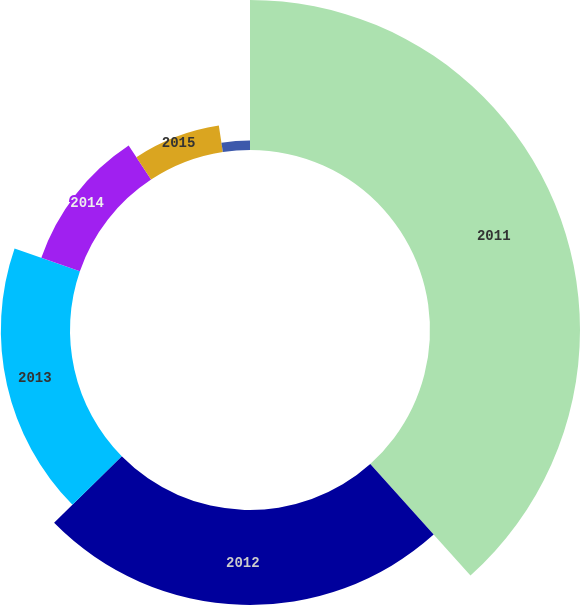<chart> <loc_0><loc_0><loc_500><loc_500><pie_chart><fcel>2011<fcel>2012<fcel>2013<fcel>2014<fcel>2015<fcel>Thereafter<nl><fcel>38.36%<fcel>24.27%<fcel>17.68%<fcel>10.44%<fcel>6.85%<fcel>2.41%<nl></chart> 